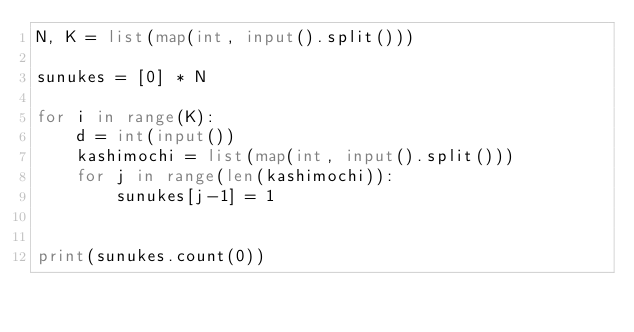Convert code to text. <code><loc_0><loc_0><loc_500><loc_500><_Python_>N, K = list(map(int, input().split()))

sunukes = [0] * N

for i in range(K):
    d = int(input())
    kashimochi = list(map(int, input().split()))
    for j in range(len(kashimochi)):
        sunukes[j-1] = 1


print(sunukes.count(0))</code> 